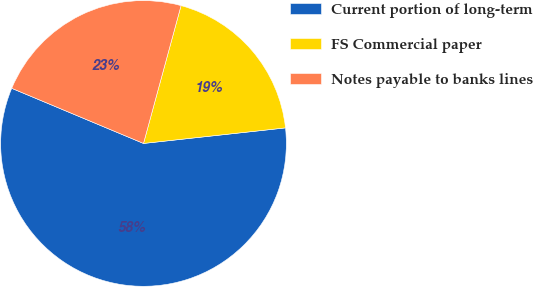Convert chart to OTSL. <chart><loc_0><loc_0><loc_500><loc_500><pie_chart><fcel>Current portion of long-term<fcel>FS Commercial paper<fcel>Notes payable to banks lines<nl><fcel>58.05%<fcel>19.03%<fcel>22.93%<nl></chart> 